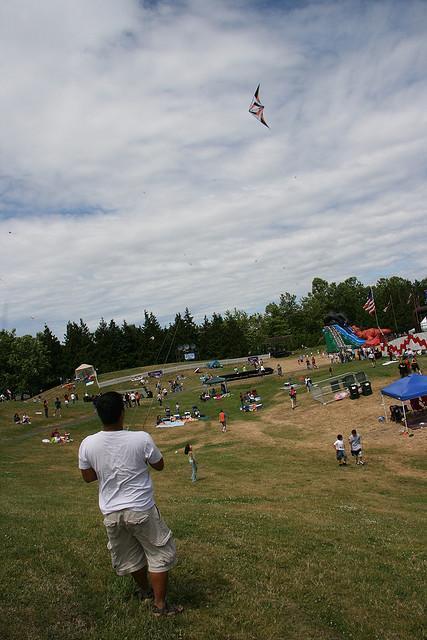How many people are visible?
Give a very brief answer. 2. How many horses are in this photo?
Give a very brief answer. 0. 